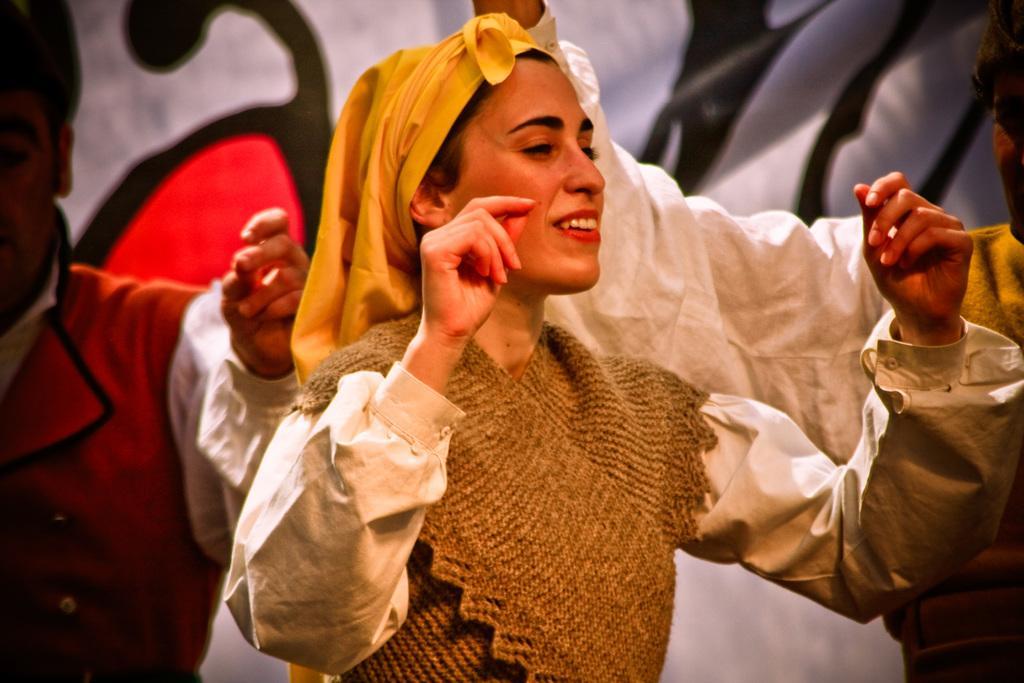Can you describe this image briefly? In the center of the image we can see a woman. On the backside we can see some people and a banner. 